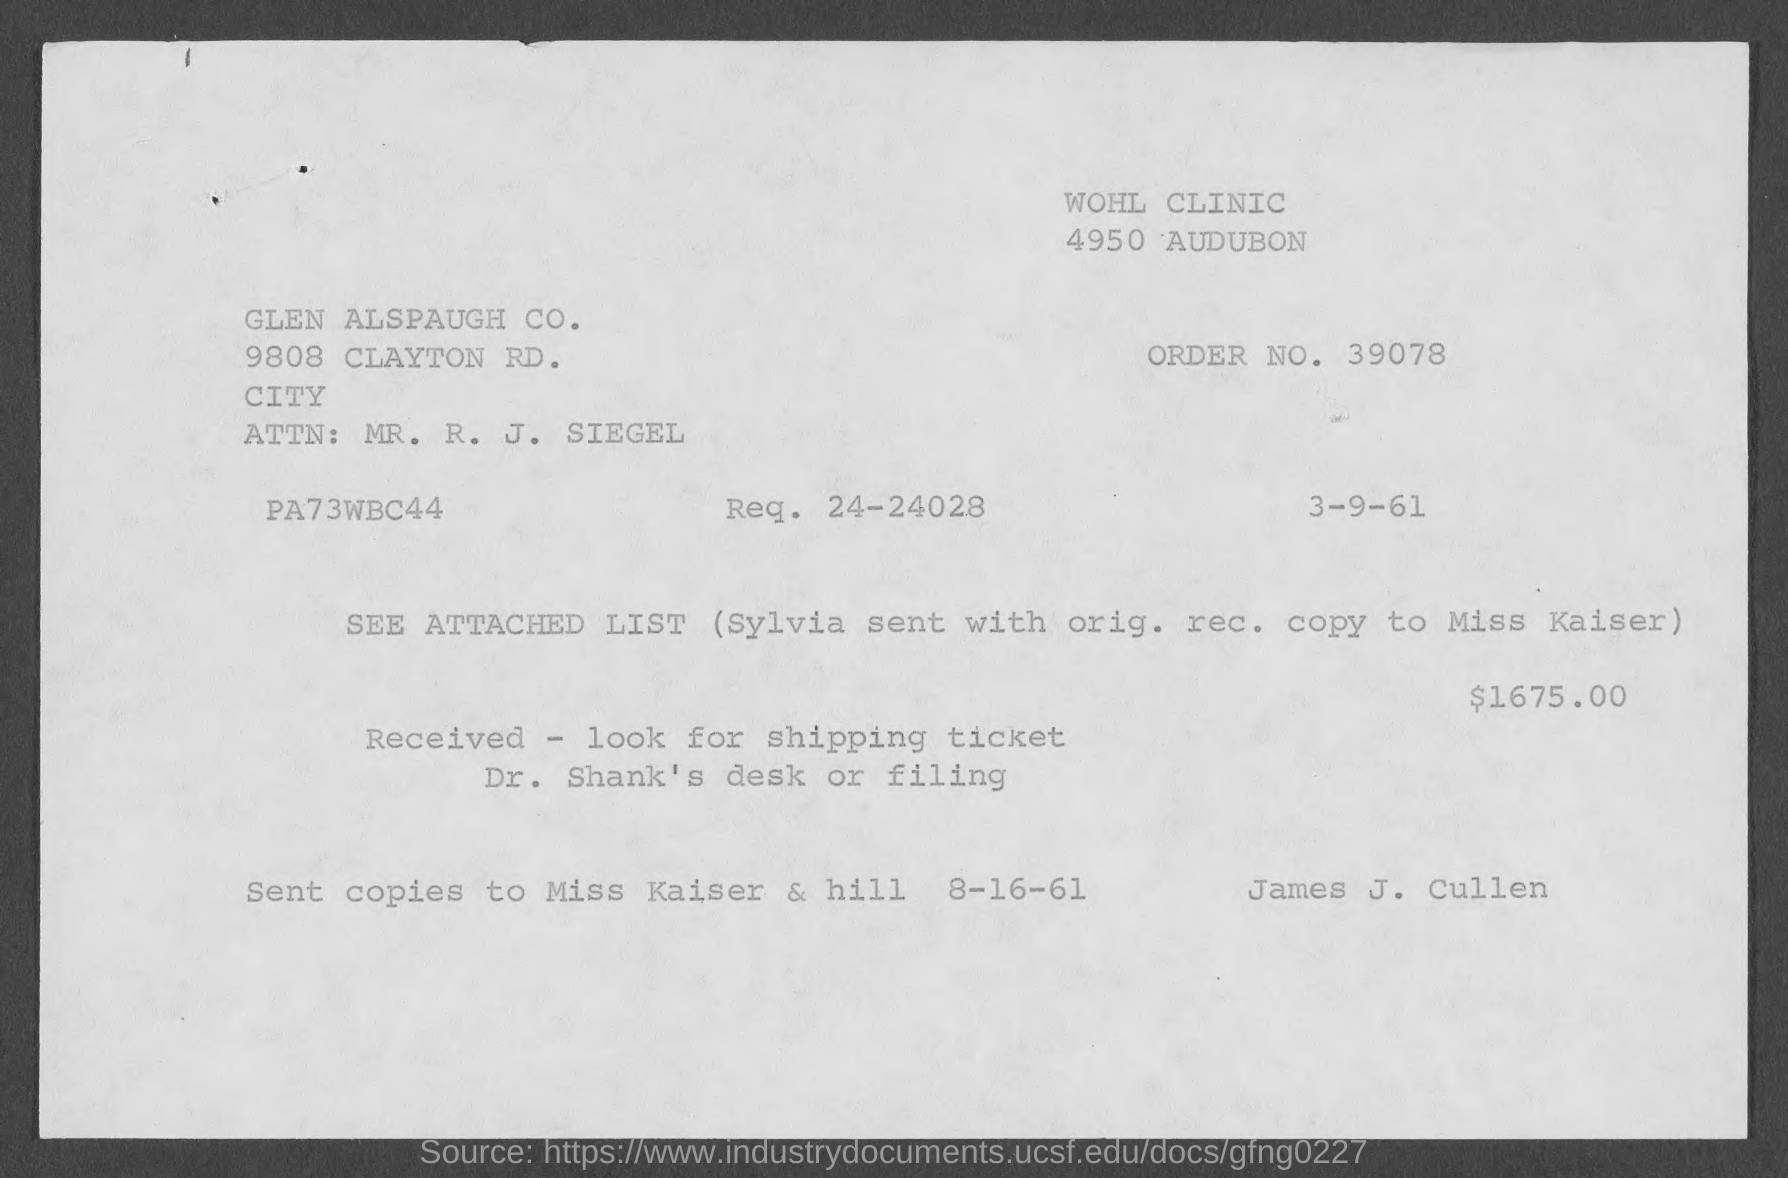What is the order no. mentioned in the given page ?
Ensure brevity in your answer.  39078. What is the req no. mentioned in the given page ?
Your response must be concise. 24-24028. 